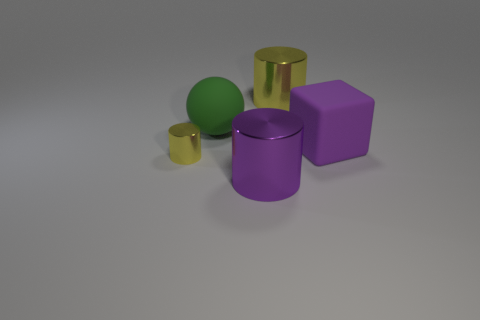The small metallic cylinder has what color? yellow 